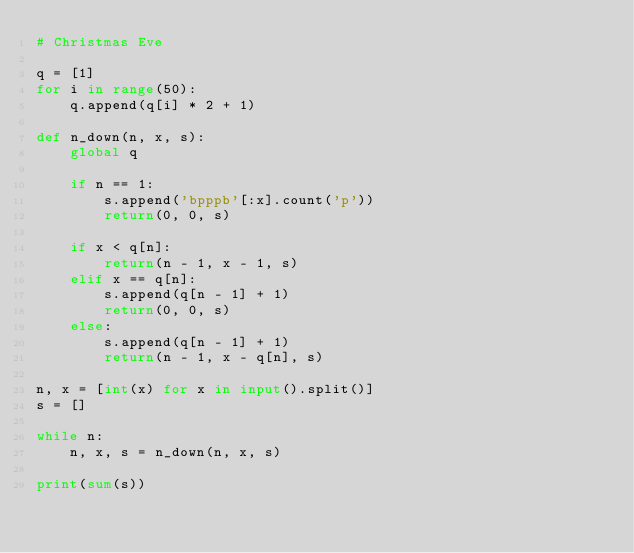Convert code to text. <code><loc_0><loc_0><loc_500><loc_500><_Python_># Christmas Eve

q = [1]
for i in range(50):
    q.append(q[i] * 2 + 1)

def n_down(n, x, s):
    global q

    if n == 1:
        s.append('bpppb'[:x].count('p'))
        return(0, 0, s)

    if x < q[n]:
        return(n - 1, x - 1, s)
    elif x == q[n]:
        s.append(q[n - 1] + 1)
        return(0, 0, s)
    else:
        s.append(q[n - 1] + 1)
        return(n - 1, x - q[n], s)

n, x = [int(x) for x in input().split()]
s = []

while n:
    n, x, s = n_down(n, x, s)

print(sum(s))
</code> 